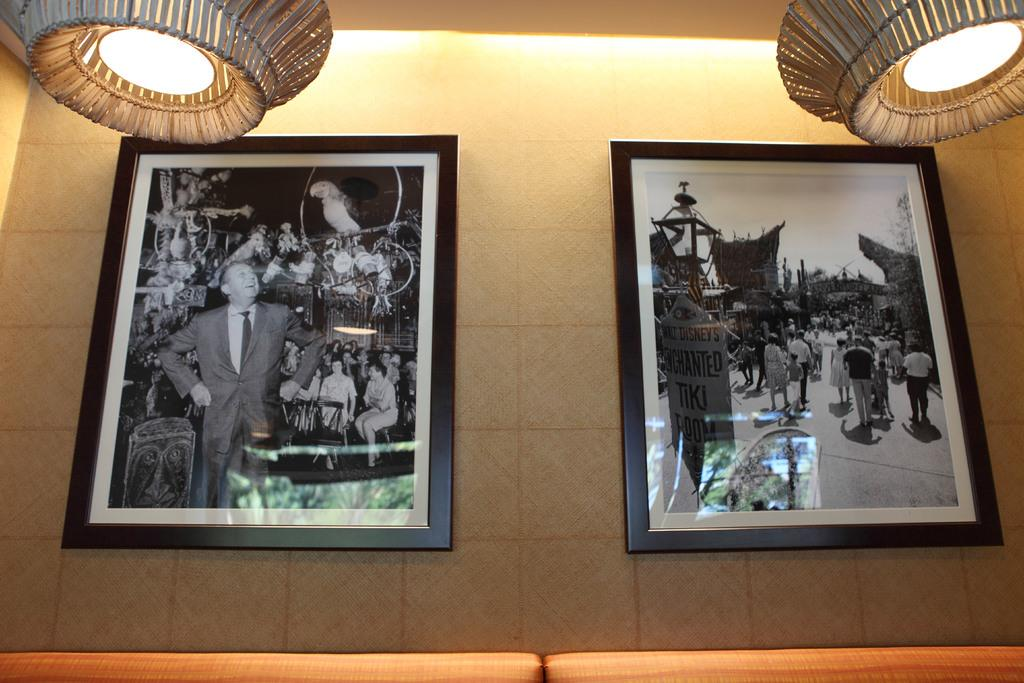How many photo frames are on the wall in the image? There are two photo frames on the wall in the image. What can be seen inside the photo frames? The photo frames contain pictures of people. What else can be seen in the image besides the photo frames? There are lights visible in the image. What type of floor can be seen in the image? There is no information about the floor in the image, as the focus is on the photo frames and lights. 